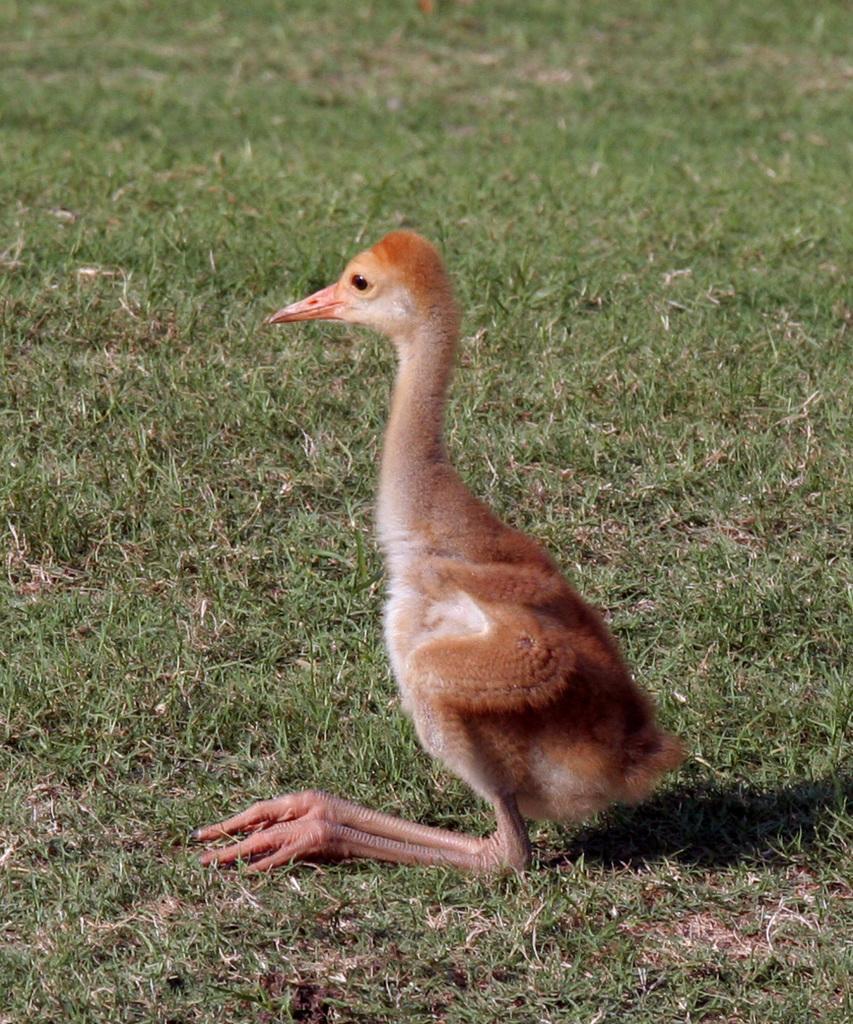Please provide a concise description of this image. In this image I can see a brown colour bird. I can also see grass and a shadow over here. 